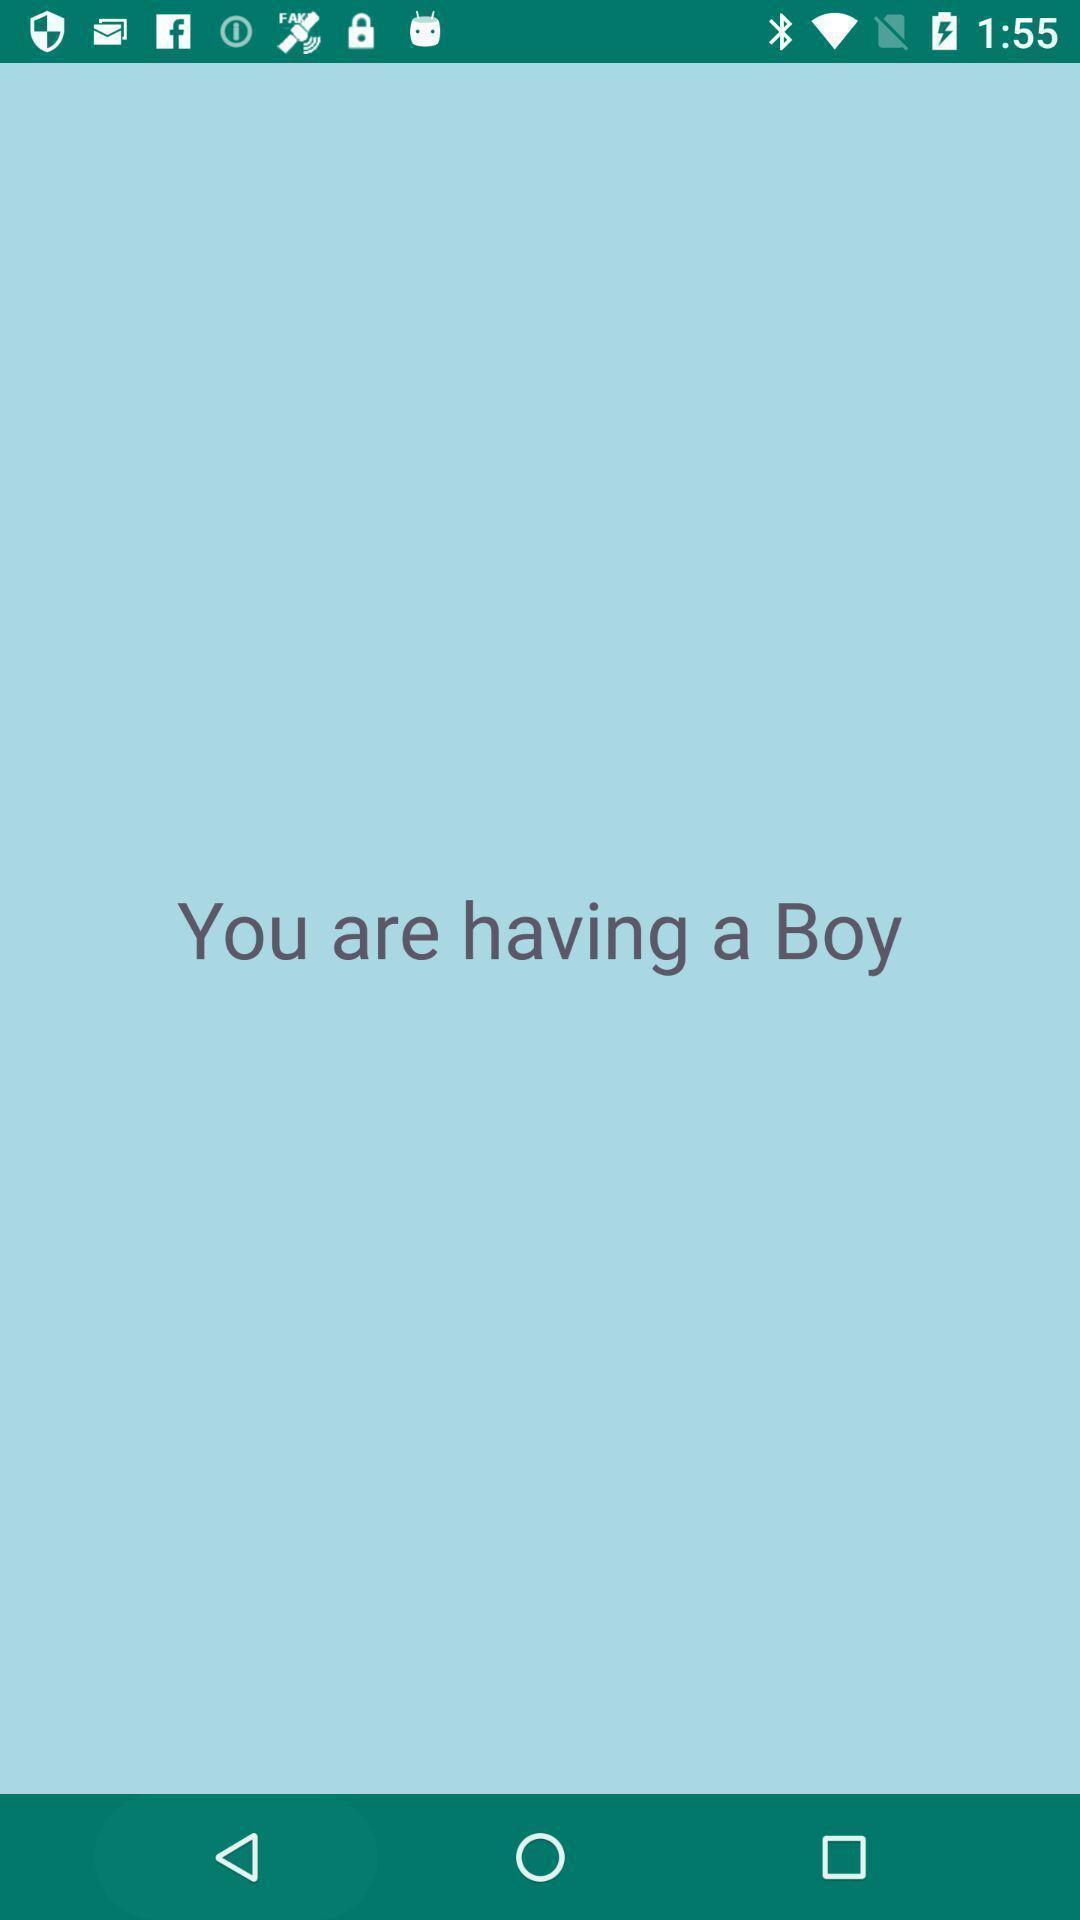Describe the key features of this screenshot. Screen shows you are having a boy in health app. 